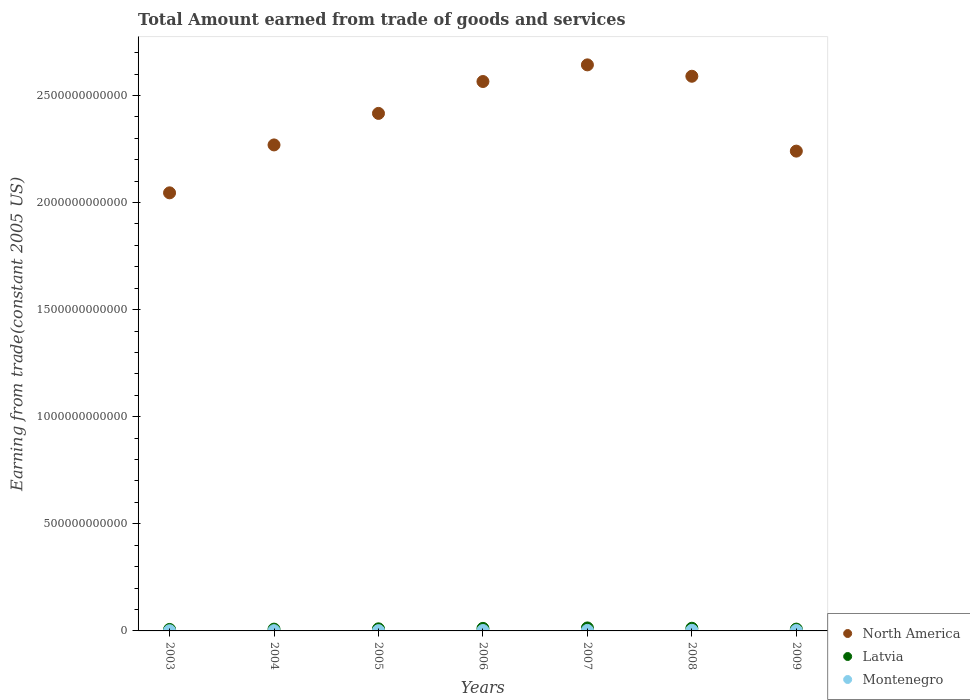How many different coloured dotlines are there?
Offer a terse response. 3. Is the number of dotlines equal to the number of legend labels?
Your answer should be very brief. Yes. What is the total amount earned by trading goods and services in Montenegro in 2009?
Offer a terse response. 2.00e+09. Across all years, what is the maximum total amount earned by trading goods and services in Montenegro?
Offer a terse response. 2.87e+09. Across all years, what is the minimum total amount earned by trading goods and services in North America?
Your answer should be compact. 2.05e+12. In which year was the total amount earned by trading goods and services in Montenegro maximum?
Your answer should be very brief. 2008. In which year was the total amount earned by trading goods and services in North America minimum?
Make the answer very short. 2003. What is the total total amount earned by trading goods and services in Montenegro in the graph?
Your answer should be compact. 1.29e+1. What is the difference between the total amount earned by trading goods and services in Montenegro in 2008 and that in 2009?
Give a very brief answer. 8.67e+08. What is the difference between the total amount earned by trading goods and services in North America in 2006 and the total amount earned by trading goods and services in Montenegro in 2005?
Provide a succinct answer. 2.56e+12. What is the average total amount earned by trading goods and services in Latvia per year?
Your answer should be very brief. 1.02e+1. In the year 2003, what is the difference between the total amount earned by trading goods and services in Latvia and total amount earned by trading goods and services in North America?
Offer a very short reply. -2.04e+12. In how many years, is the total amount earned by trading goods and services in Montenegro greater than 100000000000 US$?
Give a very brief answer. 0. What is the ratio of the total amount earned by trading goods and services in North America in 2004 to that in 2005?
Your answer should be compact. 0.94. Is the total amount earned by trading goods and services in North America in 2003 less than that in 2004?
Provide a succinct answer. Yes. Is the difference between the total amount earned by trading goods and services in Latvia in 2005 and 2009 greater than the difference between the total amount earned by trading goods and services in North America in 2005 and 2009?
Keep it short and to the point. No. What is the difference between the highest and the second highest total amount earned by trading goods and services in North America?
Keep it short and to the point. 5.31e+1. What is the difference between the highest and the lowest total amount earned by trading goods and services in North America?
Your answer should be compact. 5.97e+11. In how many years, is the total amount earned by trading goods and services in Latvia greater than the average total amount earned by trading goods and services in Latvia taken over all years?
Your answer should be compact. 3. Is the sum of the total amount earned by trading goods and services in Montenegro in 2005 and 2008 greater than the maximum total amount earned by trading goods and services in Latvia across all years?
Offer a very short reply. No. Does the total amount earned by trading goods and services in Montenegro monotonically increase over the years?
Your answer should be compact. No. Is the total amount earned by trading goods and services in North America strictly greater than the total amount earned by trading goods and services in Latvia over the years?
Give a very brief answer. Yes. How many dotlines are there?
Offer a very short reply. 3. What is the difference between two consecutive major ticks on the Y-axis?
Make the answer very short. 5.00e+11. Are the values on the major ticks of Y-axis written in scientific E-notation?
Offer a terse response. No. Does the graph contain grids?
Your response must be concise. No. Where does the legend appear in the graph?
Ensure brevity in your answer.  Bottom right. How many legend labels are there?
Make the answer very short. 3. What is the title of the graph?
Your response must be concise. Total Amount earned from trade of goods and services. What is the label or title of the Y-axis?
Give a very brief answer. Earning from trade(constant 2005 US). What is the Earning from trade(constant 2005 US) of North America in 2003?
Ensure brevity in your answer.  2.05e+12. What is the Earning from trade(constant 2005 US) in Latvia in 2003?
Provide a succinct answer. 6.90e+09. What is the Earning from trade(constant 2005 US) in Montenegro in 2003?
Keep it short and to the point. 9.18e+08. What is the Earning from trade(constant 2005 US) of North America in 2004?
Give a very brief answer. 2.27e+12. What is the Earning from trade(constant 2005 US) of Latvia in 2004?
Offer a very short reply. 8.35e+09. What is the Earning from trade(constant 2005 US) in Montenegro in 2004?
Your answer should be compact. 1.21e+09. What is the Earning from trade(constant 2005 US) of North America in 2005?
Your response must be concise. 2.42e+12. What is the Earning from trade(constant 2005 US) in Latvia in 2005?
Provide a succinct answer. 9.76e+09. What is the Earning from trade(constant 2005 US) in Montenegro in 2005?
Your response must be concise. 1.38e+09. What is the Earning from trade(constant 2005 US) of North America in 2006?
Make the answer very short. 2.56e+12. What is the Earning from trade(constant 2005 US) of Latvia in 2006?
Offer a very short reply. 1.18e+1. What is the Earning from trade(constant 2005 US) in Montenegro in 2006?
Your response must be concise. 2.00e+09. What is the Earning from trade(constant 2005 US) in North America in 2007?
Keep it short and to the point. 2.64e+12. What is the Earning from trade(constant 2005 US) in Latvia in 2007?
Give a very brief answer. 1.39e+1. What is the Earning from trade(constant 2005 US) of Montenegro in 2007?
Your response must be concise. 2.49e+09. What is the Earning from trade(constant 2005 US) in North America in 2008?
Ensure brevity in your answer.  2.59e+12. What is the Earning from trade(constant 2005 US) in Latvia in 2008?
Give a very brief answer. 1.24e+1. What is the Earning from trade(constant 2005 US) in Montenegro in 2008?
Provide a succinct answer. 2.87e+09. What is the Earning from trade(constant 2005 US) of North America in 2009?
Offer a terse response. 2.24e+12. What is the Earning from trade(constant 2005 US) of Latvia in 2009?
Offer a very short reply. 8.47e+09. What is the Earning from trade(constant 2005 US) in Montenegro in 2009?
Provide a succinct answer. 2.00e+09. Across all years, what is the maximum Earning from trade(constant 2005 US) of North America?
Offer a terse response. 2.64e+12. Across all years, what is the maximum Earning from trade(constant 2005 US) in Latvia?
Ensure brevity in your answer.  1.39e+1. Across all years, what is the maximum Earning from trade(constant 2005 US) of Montenegro?
Your answer should be very brief. 2.87e+09. Across all years, what is the minimum Earning from trade(constant 2005 US) in North America?
Provide a short and direct response. 2.05e+12. Across all years, what is the minimum Earning from trade(constant 2005 US) in Latvia?
Make the answer very short. 6.90e+09. Across all years, what is the minimum Earning from trade(constant 2005 US) in Montenegro?
Give a very brief answer. 9.18e+08. What is the total Earning from trade(constant 2005 US) of North America in the graph?
Give a very brief answer. 1.68e+13. What is the total Earning from trade(constant 2005 US) of Latvia in the graph?
Give a very brief answer. 7.16e+1. What is the total Earning from trade(constant 2005 US) in Montenegro in the graph?
Keep it short and to the point. 1.29e+1. What is the difference between the Earning from trade(constant 2005 US) in North America in 2003 and that in 2004?
Provide a short and direct response. -2.24e+11. What is the difference between the Earning from trade(constant 2005 US) in Latvia in 2003 and that in 2004?
Provide a short and direct response. -1.45e+09. What is the difference between the Earning from trade(constant 2005 US) of Montenegro in 2003 and that in 2004?
Offer a terse response. -2.95e+08. What is the difference between the Earning from trade(constant 2005 US) in North America in 2003 and that in 2005?
Provide a short and direct response. -3.71e+11. What is the difference between the Earning from trade(constant 2005 US) in Latvia in 2003 and that in 2005?
Your response must be concise. -2.86e+09. What is the difference between the Earning from trade(constant 2005 US) of Montenegro in 2003 and that in 2005?
Your response must be concise. -4.61e+08. What is the difference between the Earning from trade(constant 2005 US) of North America in 2003 and that in 2006?
Offer a very short reply. -5.20e+11. What is the difference between the Earning from trade(constant 2005 US) of Latvia in 2003 and that in 2006?
Offer a terse response. -4.95e+09. What is the difference between the Earning from trade(constant 2005 US) of Montenegro in 2003 and that in 2006?
Offer a very short reply. -1.08e+09. What is the difference between the Earning from trade(constant 2005 US) in North America in 2003 and that in 2007?
Keep it short and to the point. -5.97e+11. What is the difference between the Earning from trade(constant 2005 US) of Latvia in 2003 and that in 2007?
Make the answer very short. -7.00e+09. What is the difference between the Earning from trade(constant 2005 US) in Montenegro in 2003 and that in 2007?
Give a very brief answer. -1.57e+09. What is the difference between the Earning from trade(constant 2005 US) in North America in 2003 and that in 2008?
Provide a short and direct response. -5.44e+11. What is the difference between the Earning from trade(constant 2005 US) of Latvia in 2003 and that in 2008?
Ensure brevity in your answer.  -5.51e+09. What is the difference between the Earning from trade(constant 2005 US) in Montenegro in 2003 and that in 2008?
Offer a terse response. -1.95e+09. What is the difference between the Earning from trade(constant 2005 US) of North America in 2003 and that in 2009?
Your answer should be compact. -1.95e+11. What is the difference between the Earning from trade(constant 2005 US) in Latvia in 2003 and that in 2009?
Your response must be concise. -1.57e+09. What is the difference between the Earning from trade(constant 2005 US) of Montenegro in 2003 and that in 2009?
Your answer should be compact. -1.08e+09. What is the difference between the Earning from trade(constant 2005 US) of North America in 2004 and that in 2005?
Ensure brevity in your answer.  -1.47e+11. What is the difference between the Earning from trade(constant 2005 US) in Latvia in 2004 and that in 2005?
Offer a very short reply. -1.41e+09. What is the difference between the Earning from trade(constant 2005 US) in Montenegro in 2004 and that in 2005?
Ensure brevity in your answer.  -1.66e+08. What is the difference between the Earning from trade(constant 2005 US) of North America in 2004 and that in 2006?
Keep it short and to the point. -2.96e+11. What is the difference between the Earning from trade(constant 2005 US) in Latvia in 2004 and that in 2006?
Your answer should be very brief. -3.49e+09. What is the difference between the Earning from trade(constant 2005 US) of Montenegro in 2004 and that in 2006?
Your answer should be compact. -7.86e+08. What is the difference between the Earning from trade(constant 2005 US) of North America in 2004 and that in 2007?
Keep it short and to the point. -3.74e+11. What is the difference between the Earning from trade(constant 2005 US) in Latvia in 2004 and that in 2007?
Your response must be concise. -5.55e+09. What is the difference between the Earning from trade(constant 2005 US) of Montenegro in 2004 and that in 2007?
Your answer should be very brief. -1.28e+09. What is the difference between the Earning from trade(constant 2005 US) in North America in 2004 and that in 2008?
Your response must be concise. -3.21e+11. What is the difference between the Earning from trade(constant 2005 US) in Latvia in 2004 and that in 2008?
Provide a succinct answer. -4.06e+09. What is the difference between the Earning from trade(constant 2005 US) in Montenegro in 2004 and that in 2008?
Keep it short and to the point. -1.66e+09. What is the difference between the Earning from trade(constant 2005 US) of North America in 2004 and that in 2009?
Your response must be concise. 2.89e+1. What is the difference between the Earning from trade(constant 2005 US) of Latvia in 2004 and that in 2009?
Offer a terse response. -1.23e+08. What is the difference between the Earning from trade(constant 2005 US) of Montenegro in 2004 and that in 2009?
Your response must be concise. -7.88e+08. What is the difference between the Earning from trade(constant 2005 US) in North America in 2005 and that in 2006?
Your answer should be very brief. -1.49e+11. What is the difference between the Earning from trade(constant 2005 US) of Latvia in 2005 and that in 2006?
Offer a very short reply. -2.09e+09. What is the difference between the Earning from trade(constant 2005 US) of Montenegro in 2005 and that in 2006?
Ensure brevity in your answer.  -6.21e+08. What is the difference between the Earning from trade(constant 2005 US) in North America in 2005 and that in 2007?
Your answer should be very brief. -2.27e+11. What is the difference between the Earning from trade(constant 2005 US) in Latvia in 2005 and that in 2007?
Your response must be concise. -4.14e+09. What is the difference between the Earning from trade(constant 2005 US) in Montenegro in 2005 and that in 2007?
Your response must be concise. -1.11e+09. What is the difference between the Earning from trade(constant 2005 US) in North America in 2005 and that in 2008?
Offer a terse response. -1.73e+11. What is the difference between the Earning from trade(constant 2005 US) of Latvia in 2005 and that in 2008?
Your response must be concise. -2.65e+09. What is the difference between the Earning from trade(constant 2005 US) of Montenegro in 2005 and that in 2008?
Offer a terse response. -1.49e+09. What is the difference between the Earning from trade(constant 2005 US) of North America in 2005 and that in 2009?
Provide a short and direct response. 1.76e+11. What is the difference between the Earning from trade(constant 2005 US) of Latvia in 2005 and that in 2009?
Offer a terse response. 1.28e+09. What is the difference between the Earning from trade(constant 2005 US) in Montenegro in 2005 and that in 2009?
Provide a succinct answer. -6.23e+08. What is the difference between the Earning from trade(constant 2005 US) of North America in 2006 and that in 2007?
Your answer should be very brief. -7.77e+1. What is the difference between the Earning from trade(constant 2005 US) in Latvia in 2006 and that in 2007?
Your answer should be compact. -2.05e+09. What is the difference between the Earning from trade(constant 2005 US) of Montenegro in 2006 and that in 2007?
Your answer should be very brief. -4.90e+08. What is the difference between the Earning from trade(constant 2005 US) in North America in 2006 and that in 2008?
Provide a short and direct response. -2.46e+1. What is the difference between the Earning from trade(constant 2005 US) of Latvia in 2006 and that in 2008?
Offer a very short reply. -5.63e+08. What is the difference between the Earning from trade(constant 2005 US) of Montenegro in 2006 and that in 2008?
Offer a terse response. -8.69e+08. What is the difference between the Earning from trade(constant 2005 US) in North America in 2006 and that in 2009?
Offer a very short reply. 3.25e+11. What is the difference between the Earning from trade(constant 2005 US) of Latvia in 2006 and that in 2009?
Provide a succinct answer. 3.37e+09. What is the difference between the Earning from trade(constant 2005 US) in Montenegro in 2006 and that in 2009?
Offer a very short reply. -1.92e+06. What is the difference between the Earning from trade(constant 2005 US) in North America in 2007 and that in 2008?
Give a very brief answer. 5.31e+1. What is the difference between the Earning from trade(constant 2005 US) of Latvia in 2007 and that in 2008?
Keep it short and to the point. 1.49e+09. What is the difference between the Earning from trade(constant 2005 US) in Montenegro in 2007 and that in 2008?
Make the answer very short. -3.80e+08. What is the difference between the Earning from trade(constant 2005 US) of North America in 2007 and that in 2009?
Your response must be concise. 4.03e+11. What is the difference between the Earning from trade(constant 2005 US) in Latvia in 2007 and that in 2009?
Provide a succinct answer. 5.43e+09. What is the difference between the Earning from trade(constant 2005 US) of Montenegro in 2007 and that in 2009?
Your answer should be compact. 4.88e+08. What is the difference between the Earning from trade(constant 2005 US) in North America in 2008 and that in 2009?
Your answer should be very brief. 3.50e+11. What is the difference between the Earning from trade(constant 2005 US) in Latvia in 2008 and that in 2009?
Ensure brevity in your answer.  3.93e+09. What is the difference between the Earning from trade(constant 2005 US) of Montenegro in 2008 and that in 2009?
Your answer should be very brief. 8.67e+08. What is the difference between the Earning from trade(constant 2005 US) in North America in 2003 and the Earning from trade(constant 2005 US) in Latvia in 2004?
Your response must be concise. 2.04e+12. What is the difference between the Earning from trade(constant 2005 US) in North America in 2003 and the Earning from trade(constant 2005 US) in Montenegro in 2004?
Make the answer very short. 2.04e+12. What is the difference between the Earning from trade(constant 2005 US) of Latvia in 2003 and the Earning from trade(constant 2005 US) of Montenegro in 2004?
Provide a succinct answer. 5.69e+09. What is the difference between the Earning from trade(constant 2005 US) of North America in 2003 and the Earning from trade(constant 2005 US) of Latvia in 2005?
Keep it short and to the point. 2.04e+12. What is the difference between the Earning from trade(constant 2005 US) of North America in 2003 and the Earning from trade(constant 2005 US) of Montenegro in 2005?
Offer a terse response. 2.04e+12. What is the difference between the Earning from trade(constant 2005 US) in Latvia in 2003 and the Earning from trade(constant 2005 US) in Montenegro in 2005?
Your answer should be very brief. 5.52e+09. What is the difference between the Earning from trade(constant 2005 US) in North America in 2003 and the Earning from trade(constant 2005 US) in Latvia in 2006?
Your response must be concise. 2.03e+12. What is the difference between the Earning from trade(constant 2005 US) of North America in 2003 and the Earning from trade(constant 2005 US) of Montenegro in 2006?
Your response must be concise. 2.04e+12. What is the difference between the Earning from trade(constant 2005 US) in Latvia in 2003 and the Earning from trade(constant 2005 US) in Montenegro in 2006?
Offer a terse response. 4.90e+09. What is the difference between the Earning from trade(constant 2005 US) of North America in 2003 and the Earning from trade(constant 2005 US) of Latvia in 2007?
Provide a succinct answer. 2.03e+12. What is the difference between the Earning from trade(constant 2005 US) of North America in 2003 and the Earning from trade(constant 2005 US) of Montenegro in 2007?
Your response must be concise. 2.04e+12. What is the difference between the Earning from trade(constant 2005 US) in Latvia in 2003 and the Earning from trade(constant 2005 US) in Montenegro in 2007?
Provide a succinct answer. 4.41e+09. What is the difference between the Earning from trade(constant 2005 US) in North America in 2003 and the Earning from trade(constant 2005 US) in Latvia in 2008?
Your answer should be very brief. 2.03e+12. What is the difference between the Earning from trade(constant 2005 US) in North America in 2003 and the Earning from trade(constant 2005 US) in Montenegro in 2008?
Provide a short and direct response. 2.04e+12. What is the difference between the Earning from trade(constant 2005 US) of Latvia in 2003 and the Earning from trade(constant 2005 US) of Montenegro in 2008?
Keep it short and to the point. 4.03e+09. What is the difference between the Earning from trade(constant 2005 US) in North America in 2003 and the Earning from trade(constant 2005 US) in Latvia in 2009?
Offer a very short reply. 2.04e+12. What is the difference between the Earning from trade(constant 2005 US) in North America in 2003 and the Earning from trade(constant 2005 US) in Montenegro in 2009?
Your response must be concise. 2.04e+12. What is the difference between the Earning from trade(constant 2005 US) of Latvia in 2003 and the Earning from trade(constant 2005 US) of Montenegro in 2009?
Your answer should be compact. 4.90e+09. What is the difference between the Earning from trade(constant 2005 US) in North America in 2004 and the Earning from trade(constant 2005 US) in Latvia in 2005?
Offer a terse response. 2.26e+12. What is the difference between the Earning from trade(constant 2005 US) of North America in 2004 and the Earning from trade(constant 2005 US) of Montenegro in 2005?
Offer a very short reply. 2.27e+12. What is the difference between the Earning from trade(constant 2005 US) of Latvia in 2004 and the Earning from trade(constant 2005 US) of Montenegro in 2005?
Offer a terse response. 6.97e+09. What is the difference between the Earning from trade(constant 2005 US) of North America in 2004 and the Earning from trade(constant 2005 US) of Latvia in 2006?
Your answer should be very brief. 2.26e+12. What is the difference between the Earning from trade(constant 2005 US) of North America in 2004 and the Earning from trade(constant 2005 US) of Montenegro in 2006?
Provide a succinct answer. 2.27e+12. What is the difference between the Earning from trade(constant 2005 US) of Latvia in 2004 and the Earning from trade(constant 2005 US) of Montenegro in 2006?
Give a very brief answer. 6.35e+09. What is the difference between the Earning from trade(constant 2005 US) in North America in 2004 and the Earning from trade(constant 2005 US) in Latvia in 2007?
Keep it short and to the point. 2.26e+12. What is the difference between the Earning from trade(constant 2005 US) in North America in 2004 and the Earning from trade(constant 2005 US) in Montenegro in 2007?
Keep it short and to the point. 2.27e+12. What is the difference between the Earning from trade(constant 2005 US) of Latvia in 2004 and the Earning from trade(constant 2005 US) of Montenegro in 2007?
Provide a succinct answer. 5.86e+09. What is the difference between the Earning from trade(constant 2005 US) of North America in 2004 and the Earning from trade(constant 2005 US) of Latvia in 2008?
Make the answer very short. 2.26e+12. What is the difference between the Earning from trade(constant 2005 US) of North America in 2004 and the Earning from trade(constant 2005 US) of Montenegro in 2008?
Provide a short and direct response. 2.27e+12. What is the difference between the Earning from trade(constant 2005 US) in Latvia in 2004 and the Earning from trade(constant 2005 US) in Montenegro in 2008?
Give a very brief answer. 5.48e+09. What is the difference between the Earning from trade(constant 2005 US) of North America in 2004 and the Earning from trade(constant 2005 US) of Latvia in 2009?
Offer a terse response. 2.26e+12. What is the difference between the Earning from trade(constant 2005 US) of North America in 2004 and the Earning from trade(constant 2005 US) of Montenegro in 2009?
Your response must be concise. 2.27e+12. What is the difference between the Earning from trade(constant 2005 US) of Latvia in 2004 and the Earning from trade(constant 2005 US) of Montenegro in 2009?
Provide a succinct answer. 6.35e+09. What is the difference between the Earning from trade(constant 2005 US) in North America in 2005 and the Earning from trade(constant 2005 US) in Latvia in 2006?
Make the answer very short. 2.40e+12. What is the difference between the Earning from trade(constant 2005 US) of North America in 2005 and the Earning from trade(constant 2005 US) of Montenegro in 2006?
Give a very brief answer. 2.41e+12. What is the difference between the Earning from trade(constant 2005 US) in Latvia in 2005 and the Earning from trade(constant 2005 US) in Montenegro in 2006?
Offer a terse response. 7.76e+09. What is the difference between the Earning from trade(constant 2005 US) in North America in 2005 and the Earning from trade(constant 2005 US) in Latvia in 2007?
Provide a short and direct response. 2.40e+12. What is the difference between the Earning from trade(constant 2005 US) in North America in 2005 and the Earning from trade(constant 2005 US) in Montenegro in 2007?
Your response must be concise. 2.41e+12. What is the difference between the Earning from trade(constant 2005 US) in Latvia in 2005 and the Earning from trade(constant 2005 US) in Montenegro in 2007?
Your answer should be very brief. 7.27e+09. What is the difference between the Earning from trade(constant 2005 US) in North America in 2005 and the Earning from trade(constant 2005 US) in Latvia in 2008?
Your answer should be compact. 2.40e+12. What is the difference between the Earning from trade(constant 2005 US) in North America in 2005 and the Earning from trade(constant 2005 US) in Montenegro in 2008?
Your answer should be very brief. 2.41e+12. What is the difference between the Earning from trade(constant 2005 US) in Latvia in 2005 and the Earning from trade(constant 2005 US) in Montenegro in 2008?
Provide a succinct answer. 6.89e+09. What is the difference between the Earning from trade(constant 2005 US) in North America in 2005 and the Earning from trade(constant 2005 US) in Latvia in 2009?
Give a very brief answer. 2.41e+12. What is the difference between the Earning from trade(constant 2005 US) of North America in 2005 and the Earning from trade(constant 2005 US) of Montenegro in 2009?
Your answer should be very brief. 2.41e+12. What is the difference between the Earning from trade(constant 2005 US) in Latvia in 2005 and the Earning from trade(constant 2005 US) in Montenegro in 2009?
Give a very brief answer. 7.76e+09. What is the difference between the Earning from trade(constant 2005 US) in North America in 2006 and the Earning from trade(constant 2005 US) in Latvia in 2007?
Ensure brevity in your answer.  2.55e+12. What is the difference between the Earning from trade(constant 2005 US) of North America in 2006 and the Earning from trade(constant 2005 US) of Montenegro in 2007?
Ensure brevity in your answer.  2.56e+12. What is the difference between the Earning from trade(constant 2005 US) of Latvia in 2006 and the Earning from trade(constant 2005 US) of Montenegro in 2007?
Make the answer very short. 9.36e+09. What is the difference between the Earning from trade(constant 2005 US) in North America in 2006 and the Earning from trade(constant 2005 US) in Latvia in 2008?
Provide a succinct answer. 2.55e+12. What is the difference between the Earning from trade(constant 2005 US) of North America in 2006 and the Earning from trade(constant 2005 US) of Montenegro in 2008?
Your response must be concise. 2.56e+12. What is the difference between the Earning from trade(constant 2005 US) of Latvia in 2006 and the Earning from trade(constant 2005 US) of Montenegro in 2008?
Offer a terse response. 8.98e+09. What is the difference between the Earning from trade(constant 2005 US) in North America in 2006 and the Earning from trade(constant 2005 US) in Latvia in 2009?
Make the answer very short. 2.56e+12. What is the difference between the Earning from trade(constant 2005 US) of North America in 2006 and the Earning from trade(constant 2005 US) of Montenegro in 2009?
Your answer should be very brief. 2.56e+12. What is the difference between the Earning from trade(constant 2005 US) in Latvia in 2006 and the Earning from trade(constant 2005 US) in Montenegro in 2009?
Your answer should be compact. 9.84e+09. What is the difference between the Earning from trade(constant 2005 US) of North America in 2007 and the Earning from trade(constant 2005 US) of Latvia in 2008?
Your answer should be very brief. 2.63e+12. What is the difference between the Earning from trade(constant 2005 US) of North America in 2007 and the Earning from trade(constant 2005 US) of Montenegro in 2008?
Offer a very short reply. 2.64e+12. What is the difference between the Earning from trade(constant 2005 US) in Latvia in 2007 and the Earning from trade(constant 2005 US) in Montenegro in 2008?
Ensure brevity in your answer.  1.10e+1. What is the difference between the Earning from trade(constant 2005 US) of North America in 2007 and the Earning from trade(constant 2005 US) of Latvia in 2009?
Offer a terse response. 2.63e+12. What is the difference between the Earning from trade(constant 2005 US) in North America in 2007 and the Earning from trade(constant 2005 US) in Montenegro in 2009?
Offer a terse response. 2.64e+12. What is the difference between the Earning from trade(constant 2005 US) of Latvia in 2007 and the Earning from trade(constant 2005 US) of Montenegro in 2009?
Keep it short and to the point. 1.19e+1. What is the difference between the Earning from trade(constant 2005 US) in North America in 2008 and the Earning from trade(constant 2005 US) in Latvia in 2009?
Provide a short and direct response. 2.58e+12. What is the difference between the Earning from trade(constant 2005 US) in North America in 2008 and the Earning from trade(constant 2005 US) in Montenegro in 2009?
Offer a terse response. 2.59e+12. What is the difference between the Earning from trade(constant 2005 US) of Latvia in 2008 and the Earning from trade(constant 2005 US) of Montenegro in 2009?
Ensure brevity in your answer.  1.04e+1. What is the average Earning from trade(constant 2005 US) in North America per year?
Your answer should be very brief. 2.40e+12. What is the average Earning from trade(constant 2005 US) of Latvia per year?
Provide a short and direct response. 1.02e+1. What is the average Earning from trade(constant 2005 US) in Montenegro per year?
Make the answer very short. 1.84e+09. In the year 2003, what is the difference between the Earning from trade(constant 2005 US) in North America and Earning from trade(constant 2005 US) in Latvia?
Give a very brief answer. 2.04e+12. In the year 2003, what is the difference between the Earning from trade(constant 2005 US) in North America and Earning from trade(constant 2005 US) in Montenegro?
Your response must be concise. 2.04e+12. In the year 2003, what is the difference between the Earning from trade(constant 2005 US) in Latvia and Earning from trade(constant 2005 US) in Montenegro?
Provide a short and direct response. 5.98e+09. In the year 2004, what is the difference between the Earning from trade(constant 2005 US) of North America and Earning from trade(constant 2005 US) of Latvia?
Offer a very short reply. 2.26e+12. In the year 2004, what is the difference between the Earning from trade(constant 2005 US) in North America and Earning from trade(constant 2005 US) in Montenegro?
Offer a terse response. 2.27e+12. In the year 2004, what is the difference between the Earning from trade(constant 2005 US) in Latvia and Earning from trade(constant 2005 US) in Montenegro?
Offer a very short reply. 7.14e+09. In the year 2005, what is the difference between the Earning from trade(constant 2005 US) of North America and Earning from trade(constant 2005 US) of Latvia?
Make the answer very short. 2.41e+12. In the year 2005, what is the difference between the Earning from trade(constant 2005 US) of North America and Earning from trade(constant 2005 US) of Montenegro?
Offer a terse response. 2.41e+12. In the year 2005, what is the difference between the Earning from trade(constant 2005 US) of Latvia and Earning from trade(constant 2005 US) of Montenegro?
Offer a terse response. 8.38e+09. In the year 2006, what is the difference between the Earning from trade(constant 2005 US) of North America and Earning from trade(constant 2005 US) of Latvia?
Offer a very short reply. 2.55e+12. In the year 2006, what is the difference between the Earning from trade(constant 2005 US) in North America and Earning from trade(constant 2005 US) in Montenegro?
Keep it short and to the point. 2.56e+12. In the year 2006, what is the difference between the Earning from trade(constant 2005 US) of Latvia and Earning from trade(constant 2005 US) of Montenegro?
Ensure brevity in your answer.  9.84e+09. In the year 2007, what is the difference between the Earning from trade(constant 2005 US) of North America and Earning from trade(constant 2005 US) of Latvia?
Offer a very short reply. 2.63e+12. In the year 2007, what is the difference between the Earning from trade(constant 2005 US) in North America and Earning from trade(constant 2005 US) in Montenegro?
Your answer should be compact. 2.64e+12. In the year 2007, what is the difference between the Earning from trade(constant 2005 US) of Latvia and Earning from trade(constant 2005 US) of Montenegro?
Ensure brevity in your answer.  1.14e+1. In the year 2008, what is the difference between the Earning from trade(constant 2005 US) of North America and Earning from trade(constant 2005 US) of Latvia?
Your answer should be compact. 2.58e+12. In the year 2008, what is the difference between the Earning from trade(constant 2005 US) in North America and Earning from trade(constant 2005 US) in Montenegro?
Provide a succinct answer. 2.59e+12. In the year 2008, what is the difference between the Earning from trade(constant 2005 US) in Latvia and Earning from trade(constant 2005 US) in Montenegro?
Ensure brevity in your answer.  9.54e+09. In the year 2009, what is the difference between the Earning from trade(constant 2005 US) of North America and Earning from trade(constant 2005 US) of Latvia?
Offer a very short reply. 2.23e+12. In the year 2009, what is the difference between the Earning from trade(constant 2005 US) of North America and Earning from trade(constant 2005 US) of Montenegro?
Keep it short and to the point. 2.24e+12. In the year 2009, what is the difference between the Earning from trade(constant 2005 US) of Latvia and Earning from trade(constant 2005 US) of Montenegro?
Give a very brief answer. 6.47e+09. What is the ratio of the Earning from trade(constant 2005 US) of North America in 2003 to that in 2004?
Provide a succinct answer. 0.9. What is the ratio of the Earning from trade(constant 2005 US) of Latvia in 2003 to that in 2004?
Your answer should be very brief. 0.83. What is the ratio of the Earning from trade(constant 2005 US) in Montenegro in 2003 to that in 2004?
Your answer should be very brief. 0.76. What is the ratio of the Earning from trade(constant 2005 US) of North America in 2003 to that in 2005?
Provide a short and direct response. 0.85. What is the ratio of the Earning from trade(constant 2005 US) of Latvia in 2003 to that in 2005?
Provide a short and direct response. 0.71. What is the ratio of the Earning from trade(constant 2005 US) in Montenegro in 2003 to that in 2005?
Offer a terse response. 0.67. What is the ratio of the Earning from trade(constant 2005 US) of North America in 2003 to that in 2006?
Ensure brevity in your answer.  0.8. What is the ratio of the Earning from trade(constant 2005 US) of Latvia in 2003 to that in 2006?
Ensure brevity in your answer.  0.58. What is the ratio of the Earning from trade(constant 2005 US) of Montenegro in 2003 to that in 2006?
Give a very brief answer. 0.46. What is the ratio of the Earning from trade(constant 2005 US) of North America in 2003 to that in 2007?
Keep it short and to the point. 0.77. What is the ratio of the Earning from trade(constant 2005 US) in Latvia in 2003 to that in 2007?
Your response must be concise. 0.5. What is the ratio of the Earning from trade(constant 2005 US) of Montenegro in 2003 to that in 2007?
Your response must be concise. 0.37. What is the ratio of the Earning from trade(constant 2005 US) of North America in 2003 to that in 2008?
Keep it short and to the point. 0.79. What is the ratio of the Earning from trade(constant 2005 US) in Latvia in 2003 to that in 2008?
Keep it short and to the point. 0.56. What is the ratio of the Earning from trade(constant 2005 US) of Montenegro in 2003 to that in 2008?
Provide a short and direct response. 0.32. What is the ratio of the Earning from trade(constant 2005 US) in North America in 2003 to that in 2009?
Give a very brief answer. 0.91. What is the ratio of the Earning from trade(constant 2005 US) in Latvia in 2003 to that in 2009?
Provide a succinct answer. 0.81. What is the ratio of the Earning from trade(constant 2005 US) of Montenegro in 2003 to that in 2009?
Make the answer very short. 0.46. What is the ratio of the Earning from trade(constant 2005 US) in North America in 2004 to that in 2005?
Provide a succinct answer. 0.94. What is the ratio of the Earning from trade(constant 2005 US) in Latvia in 2004 to that in 2005?
Give a very brief answer. 0.86. What is the ratio of the Earning from trade(constant 2005 US) in Montenegro in 2004 to that in 2005?
Give a very brief answer. 0.88. What is the ratio of the Earning from trade(constant 2005 US) in North America in 2004 to that in 2006?
Your answer should be compact. 0.88. What is the ratio of the Earning from trade(constant 2005 US) in Latvia in 2004 to that in 2006?
Give a very brief answer. 0.7. What is the ratio of the Earning from trade(constant 2005 US) of Montenegro in 2004 to that in 2006?
Your answer should be compact. 0.61. What is the ratio of the Earning from trade(constant 2005 US) of North America in 2004 to that in 2007?
Give a very brief answer. 0.86. What is the ratio of the Earning from trade(constant 2005 US) of Latvia in 2004 to that in 2007?
Your answer should be very brief. 0.6. What is the ratio of the Earning from trade(constant 2005 US) of Montenegro in 2004 to that in 2007?
Make the answer very short. 0.49. What is the ratio of the Earning from trade(constant 2005 US) in North America in 2004 to that in 2008?
Make the answer very short. 0.88. What is the ratio of the Earning from trade(constant 2005 US) in Latvia in 2004 to that in 2008?
Make the answer very short. 0.67. What is the ratio of the Earning from trade(constant 2005 US) of Montenegro in 2004 to that in 2008?
Make the answer very short. 0.42. What is the ratio of the Earning from trade(constant 2005 US) of North America in 2004 to that in 2009?
Your response must be concise. 1.01. What is the ratio of the Earning from trade(constant 2005 US) in Latvia in 2004 to that in 2009?
Your response must be concise. 0.99. What is the ratio of the Earning from trade(constant 2005 US) of Montenegro in 2004 to that in 2009?
Your answer should be compact. 0.61. What is the ratio of the Earning from trade(constant 2005 US) in North America in 2005 to that in 2006?
Make the answer very short. 0.94. What is the ratio of the Earning from trade(constant 2005 US) in Latvia in 2005 to that in 2006?
Make the answer very short. 0.82. What is the ratio of the Earning from trade(constant 2005 US) in Montenegro in 2005 to that in 2006?
Give a very brief answer. 0.69. What is the ratio of the Earning from trade(constant 2005 US) of North America in 2005 to that in 2007?
Provide a succinct answer. 0.91. What is the ratio of the Earning from trade(constant 2005 US) in Latvia in 2005 to that in 2007?
Provide a succinct answer. 0.7. What is the ratio of the Earning from trade(constant 2005 US) in Montenegro in 2005 to that in 2007?
Your answer should be compact. 0.55. What is the ratio of the Earning from trade(constant 2005 US) in North America in 2005 to that in 2008?
Your response must be concise. 0.93. What is the ratio of the Earning from trade(constant 2005 US) in Latvia in 2005 to that in 2008?
Keep it short and to the point. 0.79. What is the ratio of the Earning from trade(constant 2005 US) of Montenegro in 2005 to that in 2008?
Your answer should be very brief. 0.48. What is the ratio of the Earning from trade(constant 2005 US) of North America in 2005 to that in 2009?
Provide a short and direct response. 1.08. What is the ratio of the Earning from trade(constant 2005 US) in Latvia in 2005 to that in 2009?
Provide a short and direct response. 1.15. What is the ratio of the Earning from trade(constant 2005 US) in Montenegro in 2005 to that in 2009?
Make the answer very short. 0.69. What is the ratio of the Earning from trade(constant 2005 US) in North America in 2006 to that in 2007?
Your answer should be compact. 0.97. What is the ratio of the Earning from trade(constant 2005 US) in Latvia in 2006 to that in 2007?
Your response must be concise. 0.85. What is the ratio of the Earning from trade(constant 2005 US) in Montenegro in 2006 to that in 2007?
Offer a terse response. 0.8. What is the ratio of the Earning from trade(constant 2005 US) of Latvia in 2006 to that in 2008?
Your answer should be very brief. 0.95. What is the ratio of the Earning from trade(constant 2005 US) of Montenegro in 2006 to that in 2008?
Your answer should be very brief. 0.7. What is the ratio of the Earning from trade(constant 2005 US) in North America in 2006 to that in 2009?
Offer a terse response. 1.15. What is the ratio of the Earning from trade(constant 2005 US) in Latvia in 2006 to that in 2009?
Provide a short and direct response. 1.4. What is the ratio of the Earning from trade(constant 2005 US) in Montenegro in 2006 to that in 2009?
Provide a short and direct response. 1. What is the ratio of the Earning from trade(constant 2005 US) of North America in 2007 to that in 2008?
Your answer should be compact. 1.02. What is the ratio of the Earning from trade(constant 2005 US) of Latvia in 2007 to that in 2008?
Offer a terse response. 1.12. What is the ratio of the Earning from trade(constant 2005 US) in Montenegro in 2007 to that in 2008?
Your response must be concise. 0.87. What is the ratio of the Earning from trade(constant 2005 US) of North America in 2007 to that in 2009?
Offer a terse response. 1.18. What is the ratio of the Earning from trade(constant 2005 US) of Latvia in 2007 to that in 2009?
Offer a very short reply. 1.64. What is the ratio of the Earning from trade(constant 2005 US) of Montenegro in 2007 to that in 2009?
Provide a succinct answer. 1.24. What is the ratio of the Earning from trade(constant 2005 US) in North America in 2008 to that in 2009?
Your answer should be compact. 1.16. What is the ratio of the Earning from trade(constant 2005 US) of Latvia in 2008 to that in 2009?
Your answer should be very brief. 1.46. What is the ratio of the Earning from trade(constant 2005 US) in Montenegro in 2008 to that in 2009?
Your answer should be compact. 1.43. What is the difference between the highest and the second highest Earning from trade(constant 2005 US) in North America?
Make the answer very short. 5.31e+1. What is the difference between the highest and the second highest Earning from trade(constant 2005 US) in Latvia?
Make the answer very short. 1.49e+09. What is the difference between the highest and the second highest Earning from trade(constant 2005 US) of Montenegro?
Ensure brevity in your answer.  3.80e+08. What is the difference between the highest and the lowest Earning from trade(constant 2005 US) in North America?
Provide a short and direct response. 5.97e+11. What is the difference between the highest and the lowest Earning from trade(constant 2005 US) of Latvia?
Your response must be concise. 7.00e+09. What is the difference between the highest and the lowest Earning from trade(constant 2005 US) of Montenegro?
Offer a very short reply. 1.95e+09. 